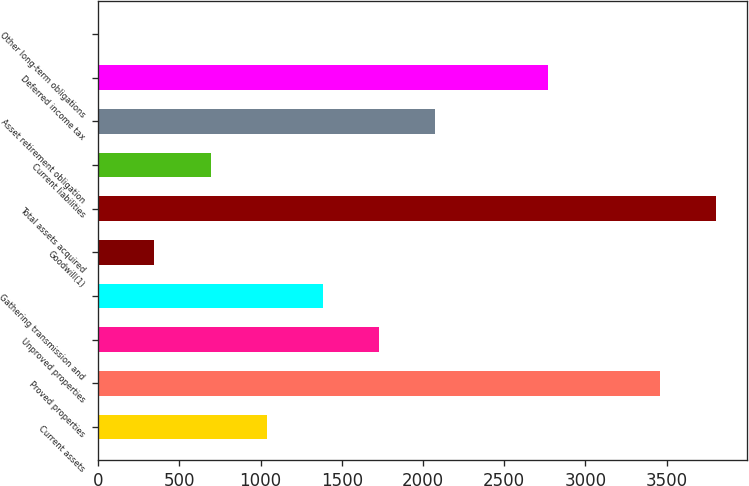Convert chart. <chart><loc_0><loc_0><loc_500><loc_500><bar_chart><fcel>Current assets<fcel>Proved properties<fcel>Unproved properties<fcel>Gathering transmission and<fcel>Goodwill(1)<fcel>Total assets acquired<fcel>Current liabilities<fcel>Asset retirement obligation<fcel>Deferred income tax<fcel>Other long-term obligations<nl><fcel>1038.1<fcel>3458<fcel>1729.5<fcel>1383.8<fcel>346.7<fcel>3803.7<fcel>692.4<fcel>2075.2<fcel>2766.6<fcel>1<nl></chart> 